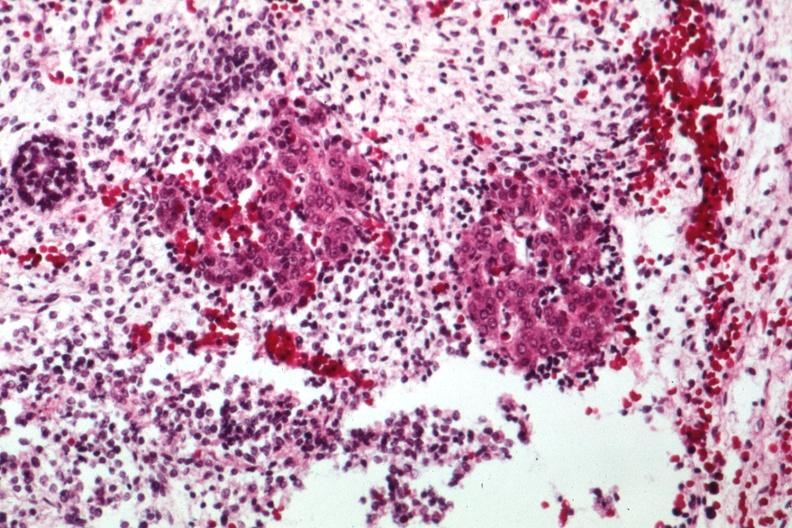s sacrococcygeal teratoma present?
Answer the question using a single word or phrase. Yes 